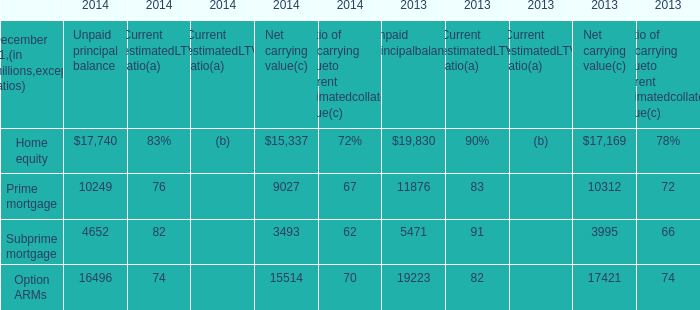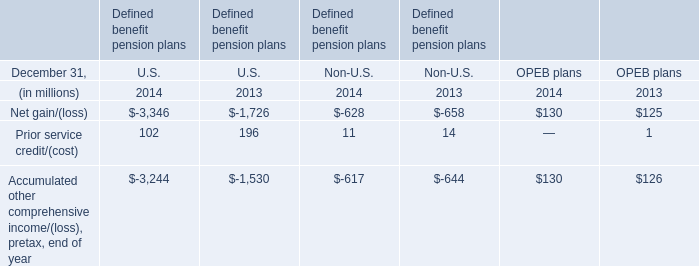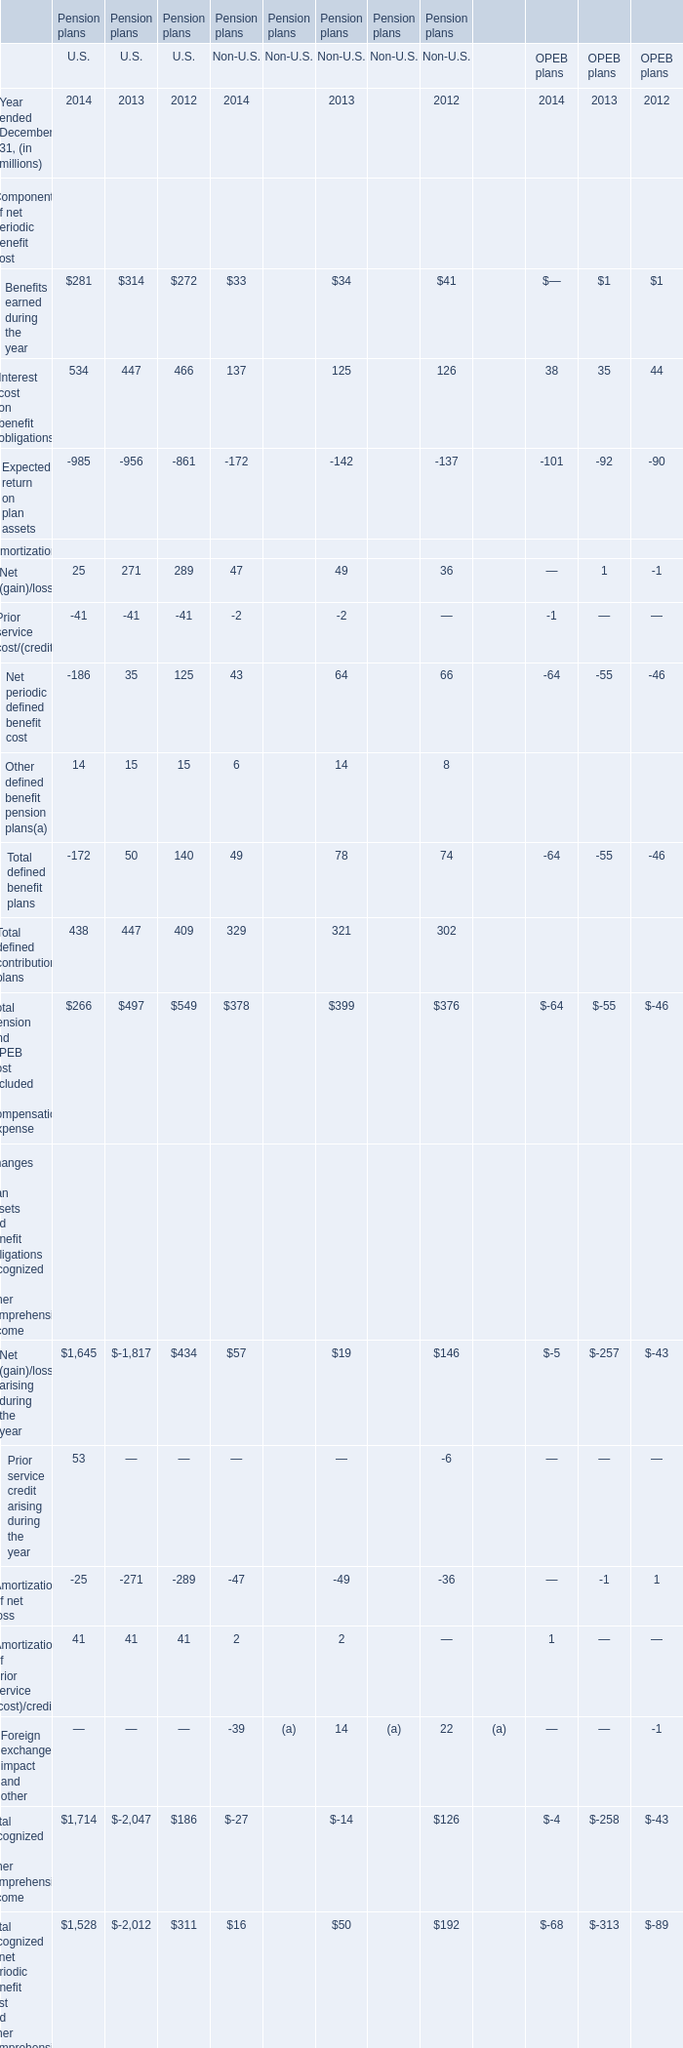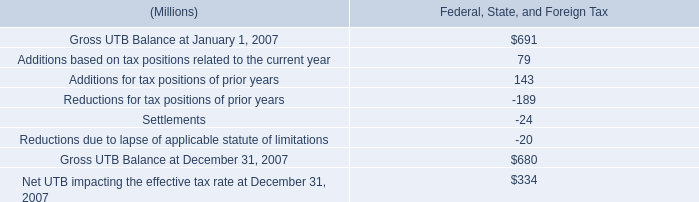What is the sum of the Interest cost on benefit obligations in the years where Benefits earned during the year greater than 320? (in million) 
Computations: (((((534 + 447) + 137) + 125) + 38) + 35)
Answer: 1316.0. 